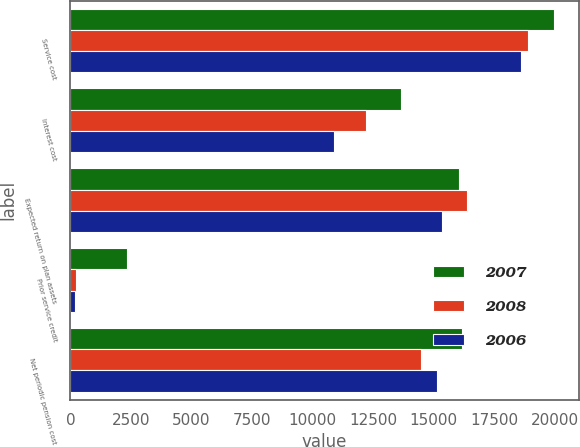<chart> <loc_0><loc_0><loc_500><loc_500><stacked_bar_chart><ecel><fcel>Service cost<fcel>Interest cost<fcel>Expected return on plan assets<fcel>Prior service credit<fcel>Net periodic pension cost<nl><fcel>2007<fcel>19980<fcel>13638<fcel>16030<fcel>2329<fcel>16161<nl><fcel>2008<fcel>18866<fcel>12191<fcel>16366<fcel>229<fcel>14462<nl><fcel>2006<fcel>18599<fcel>10869<fcel>15321<fcel>206<fcel>15140<nl></chart> 